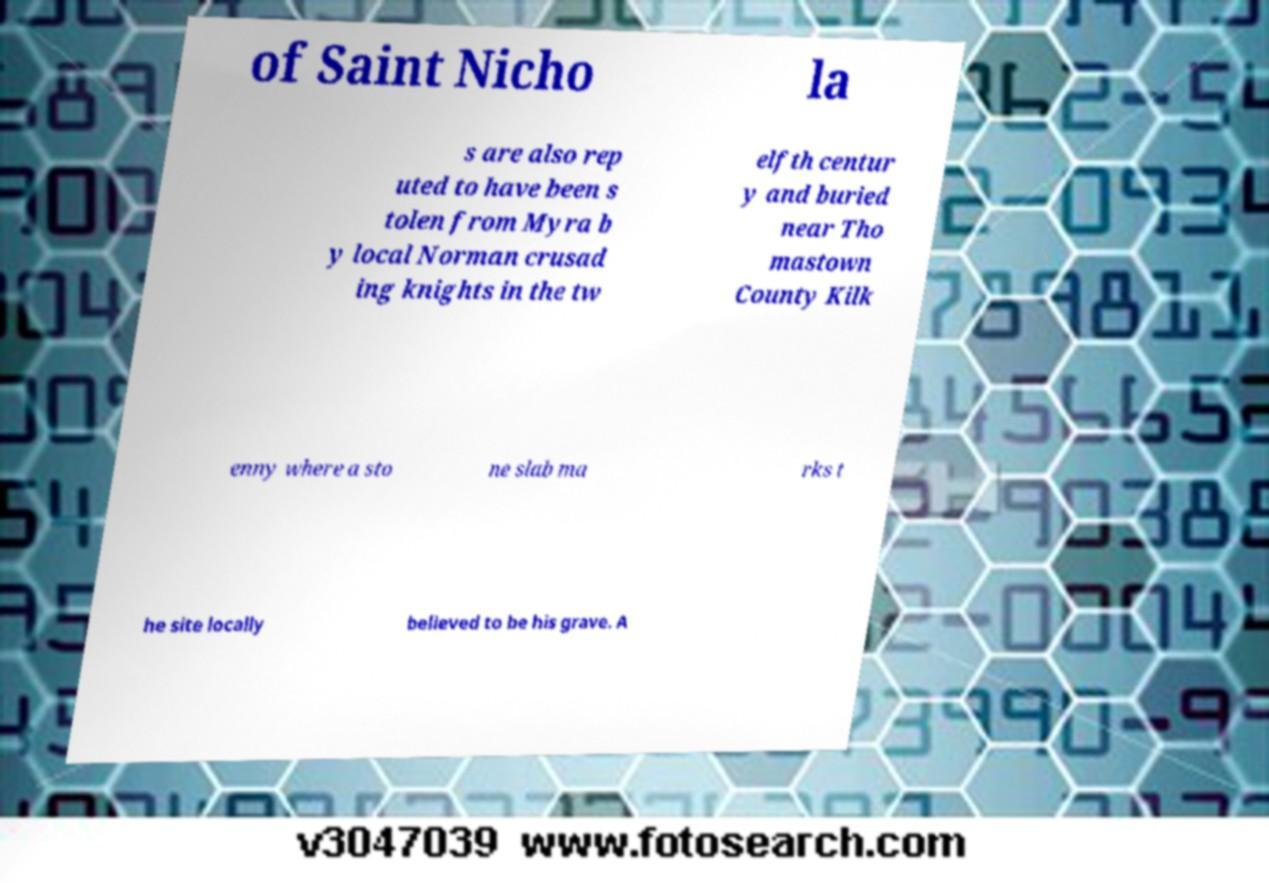What messages or text are displayed in this image? I need them in a readable, typed format. of Saint Nicho la s are also rep uted to have been s tolen from Myra b y local Norman crusad ing knights in the tw elfth centur y and buried near Tho mastown County Kilk enny where a sto ne slab ma rks t he site locally believed to be his grave. A 